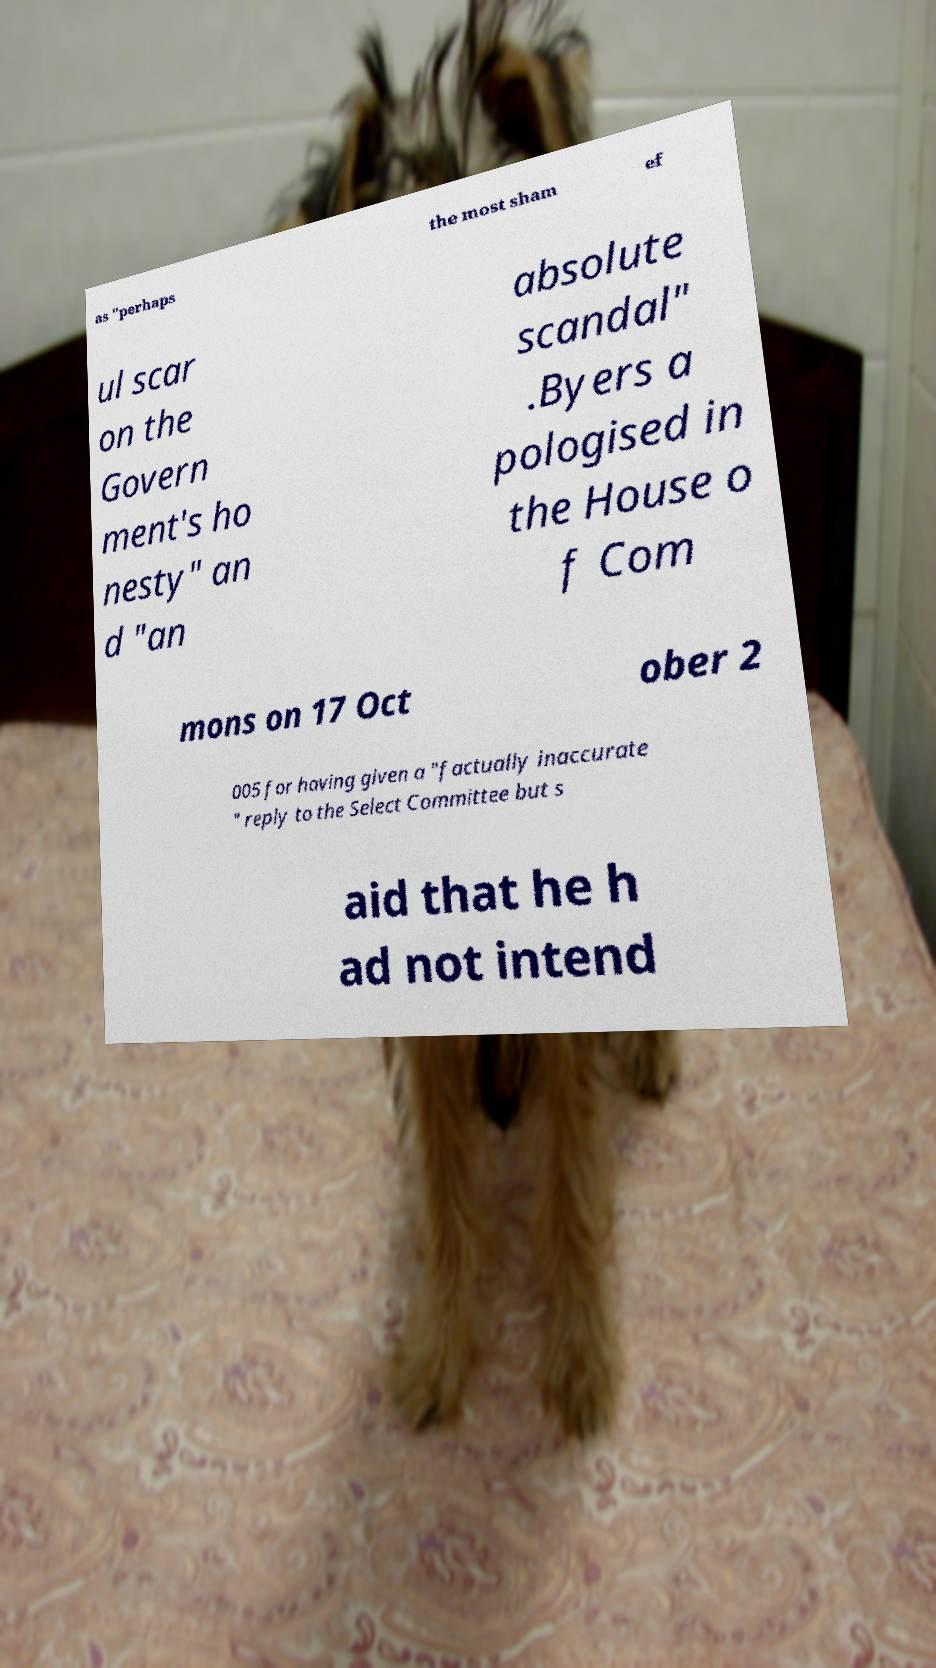I need the written content from this picture converted into text. Can you do that? as "perhaps the most sham ef ul scar on the Govern ment's ho nesty" an d "an absolute scandal" .Byers a pologised in the House o f Com mons on 17 Oct ober 2 005 for having given a "factually inaccurate " reply to the Select Committee but s aid that he h ad not intend 